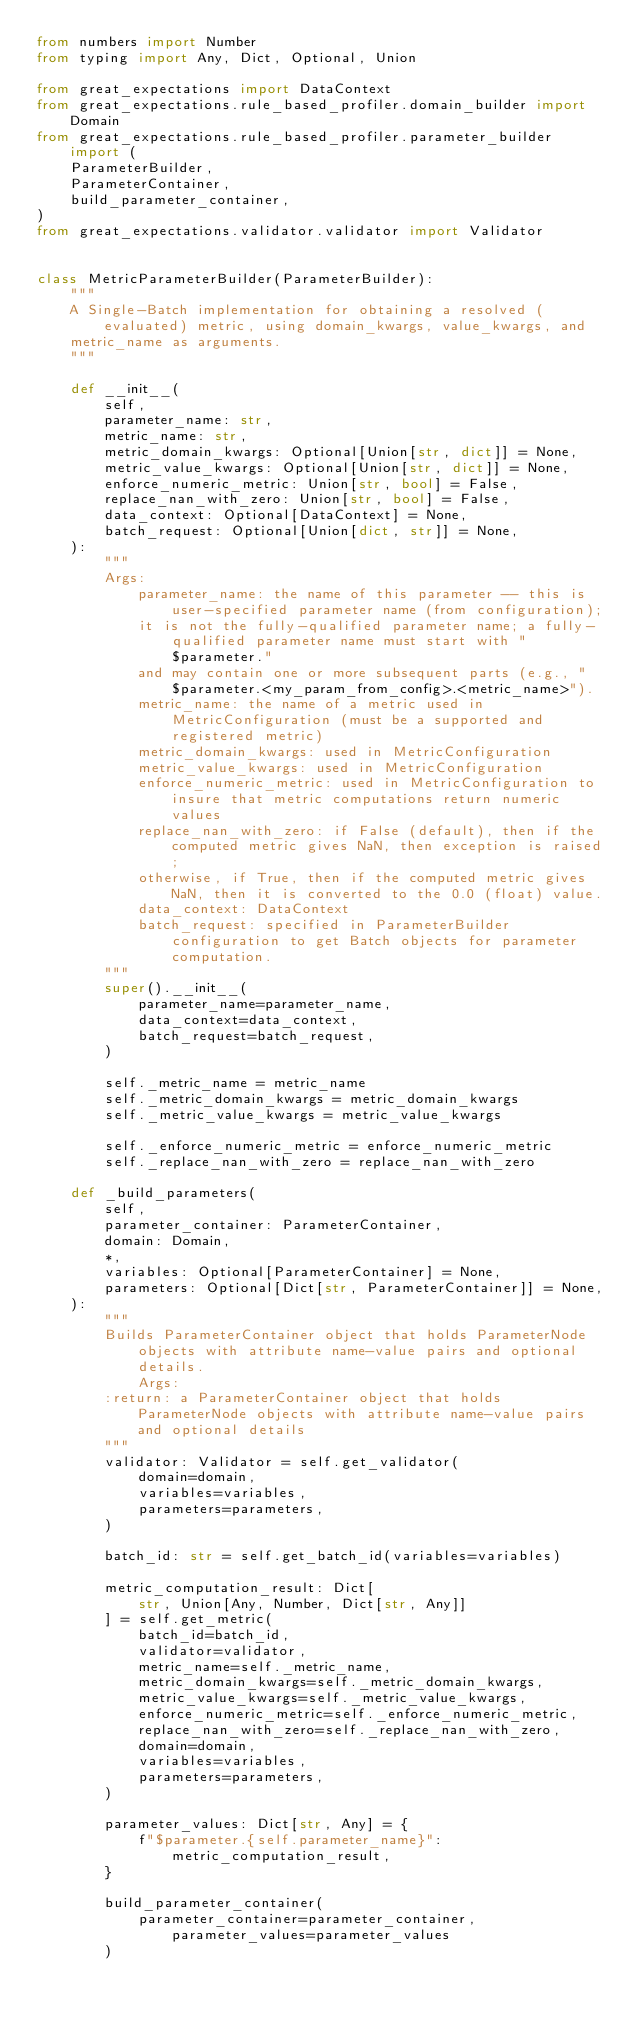<code> <loc_0><loc_0><loc_500><loc_500><_Python_>from numbers import Number
from typing import Any, Dict, Optional, Union

from great_expectations import DataContext
from great_expectations.rule_based_profiler.domain_builder import Domain
from great_expectations.rule_based_profiler.parameter_builder import (
    ParameterBuilder,
    ParameterContainer,
    build_parameter_container,
)
from great_expectations.validator.validator import Validator


class MetricParameterBuilder(ParameterBuilder):
    """
    A Single-Batch implementation for obtaining a resolved (evaluated) metric, using domain_kwargs, value_kwargs, and
    metric_name as arguments.
    """

    def __init__(
        self,
        parameter_name: str,
        metric_name: str,
        metric_domain_kwargs: Optional[Union[str, dict]] = None,
        metric_value_kwargs: Optional[Union[str, dict]] = None,
        enforce_numeric_metric: Union[str, bool] = False,
        replace_nan_with_zero: Union[str, bool] = False,
        data_context: Optional[DataContext] = None,
        batch_request: Optional[Union[dict, str]] = None,
    ):
        """
        Args:
            parameter_name: the name of this parameter -- this is user-specified parameter name (from configuration);
            it is not the fully-qualified parameter name; a fully-qualified parameter name must start with "$parameter."
            and may contain one or more subsequent parts (e.g., "$parameter.<my_param_from_config>.<metric_name>").
            metric_name: the name of a metric used in MetricConfiguration (must be a supported and registered metric)
            metric_domain_kwargs: used in MetricConfiguration
            metric_value_kwargs: used in MetricConfiguration
            enforce_numeric_metric: used in MetricConfiguration to insure that metric computations return numeric values
            replace_nan_with_zero: if False (default), then if the computed metric gives NaN, then exception is raised;
            otherwise, if True, then if the computed metric gives NaN, then it is converted to the 0.0 (float) value.
            data_context: DataContext
            batch_request: specified in ParameterBuilder configuration to get Batch objects for parameter computation.
        """
        super().__init__(
            parameter_name=parameter_name,
            data_context=data_context,
            batch_request=batch_request,
        )

        self._metric_name = metric_name
        self._metric_domain_kwargs = metric_domain_kwargs
        self._metric_value_kwargs = metric_value_kwargs

        self._enforce_numeric_metric = enforce_numeric_metric
        self._replace_nan_with_zero = replace_nan_with_zero

    def _build_parameters(
        self,
        parameter_container: ParameterContainer,
        domain: Domain,
        *,
        variables: Optional[ParameterContainer] = None,
        parameters: Optional[Dict[str, ParameterContainer]] = None,
    ):
        """
        Builds ParameterContainer object that holds ParameterNode objects with attribute name-value pairs and optional details.
            Args:
        :return: a ParameterContainer object that holds ParameterNode objects with attribute name-value pairs and optional details
        """
        validator: Validator = self.get_validator(
            domain=domain,
            variables=variables,
            parameters=parameters,
        )

        batch_id: str = self.get_batch_id(variables=variables)

        metric_computation_result: Dict[
            str, Union[Any, Number, Dict[str, Any]]
        ] = self.get_metric(
            batch_id=batch_id,
            validator=validator,
            metric_name=self._metric_name,
            metric_domain_kwargs=self._metric_domain_kwargs,
            metric_value_kwargs=self._metric_value_kwargs,
            enforce_numeric_metric=self._enforce_numeric_metric,
            replace_nan_with_zero=self._replace_nan_with_zero,
            domain=domain,
            variables=variables,
            parameters=parameters,
        )

        parameter_values: Dict[str, Any] = {
            f"$parameter.{self.parameter_name}": metric_computation_result,
        }

        build_parameter_container(
            parameter_container=parameter_container, parameter_values=parameter_values
        )
</code> 